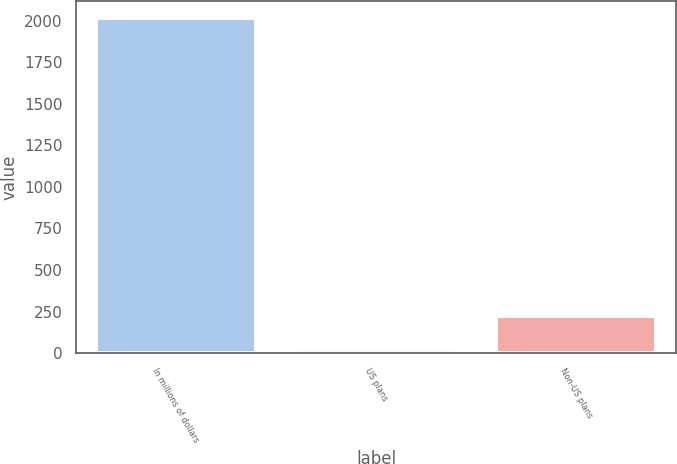<chart> <loc_0><loc_0><loc_500><loc_500><bar_chart><fcel>In millions of dollars<fcel>US plans<fcel>Non-US plans<nl><fcel>2015<fcel>26<fcel>224.9<nl></chart> 